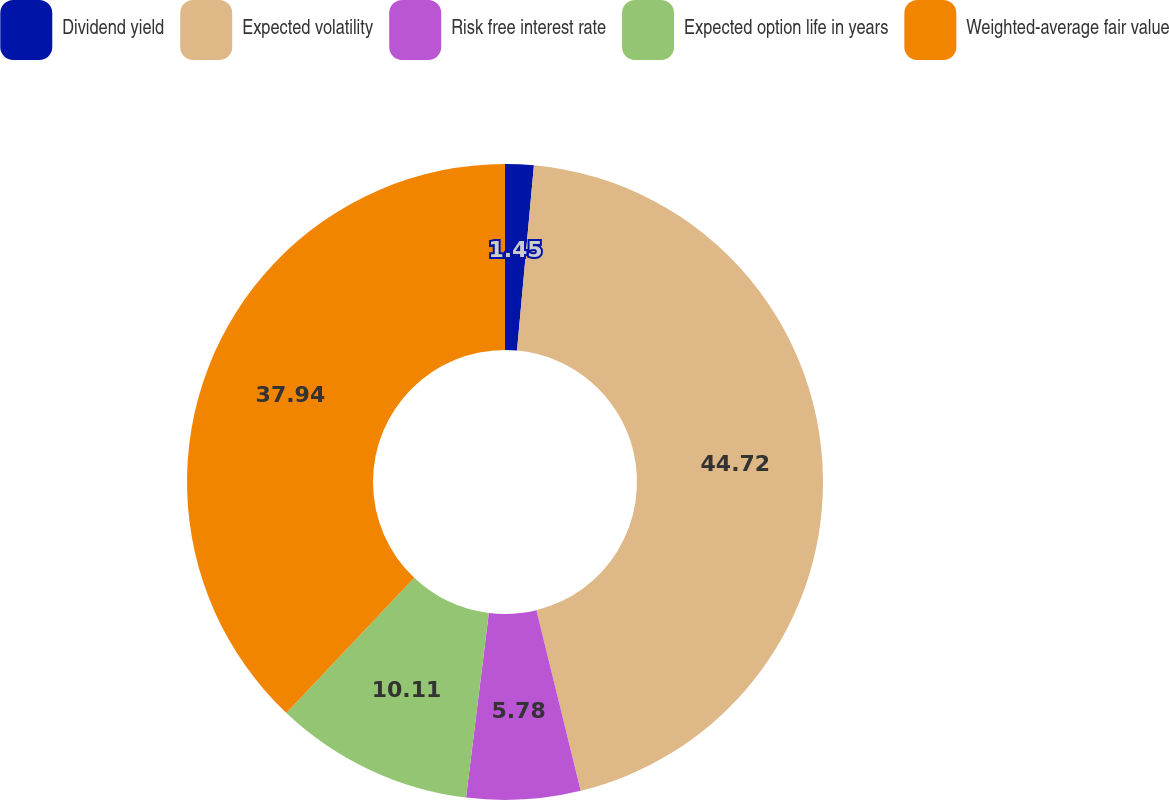<chart> <loc_0><loc_0><loc_500><loc_500><pie_chart><fcel>Dividend yield<fcel>Expected volatility<fcel>Risk free interest rate<fcel>Expected option life in years<fcel>Weighted-average fair value<nl><fcel>1.45%<fcel>44.73%<fcel>5.78%<fcel>10.11%<fcel>37.94%<nl></chart> 